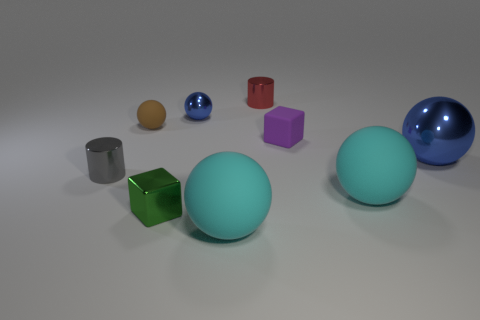How does the lighting in the image affect the appearance of the colors and shapes? The lighting in the image is coming from above and casts soft shadows beneath each object, enhancing the three-dimensional forms and emphasizing the contours of each shape. The light source highlights the shiny textures of the reflective objects, making the colors more vibrant, while the matte surfaces absorb light and appear more evenly toned. The interplay of light and shadow also contributes to our understanding of the size relationships between the different shapes. 